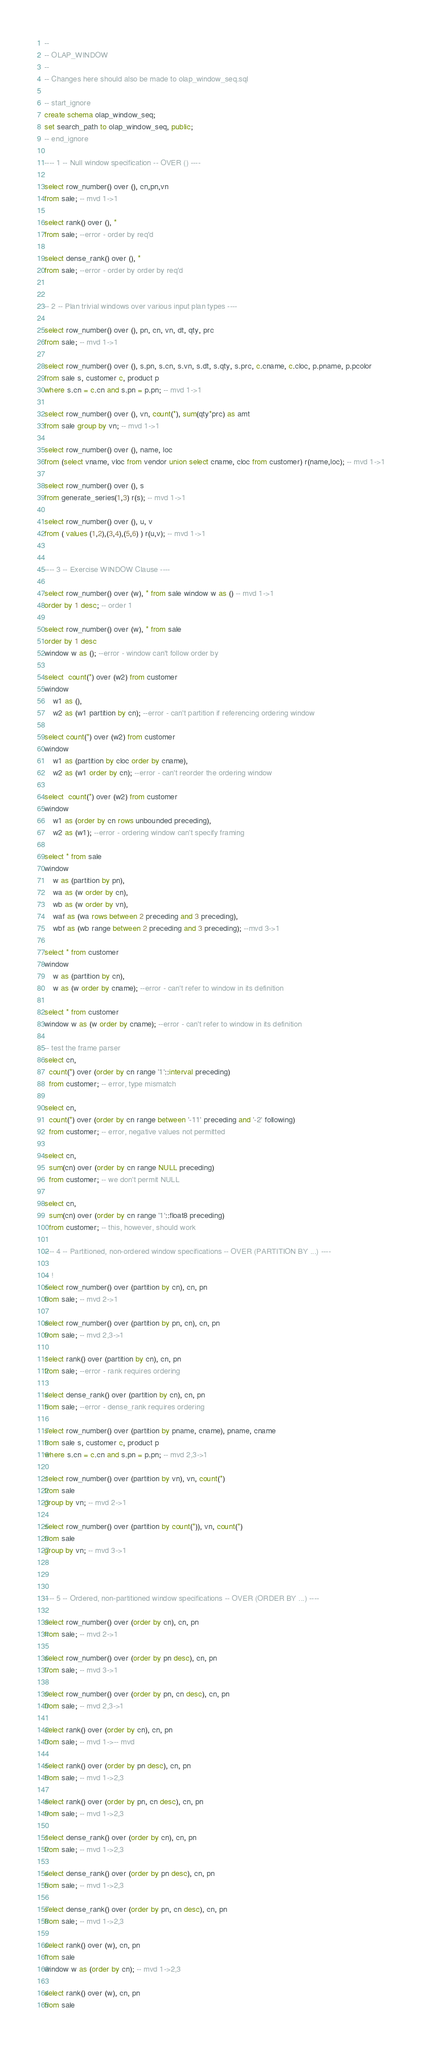Convert code to text. <code><loc_0><loc_0><loc_500><loc_500><_SQL_>--
-- OLAP_WINDOW 
--
-- Changes here should also be made to olap_window_seq.sql

-- start_ignore
create schema olap_window_seq;
set search_path to olap_window_seq, public;
-- end_ignore

---- 1 -- Null window specification -- OVER () ----

select row_number() over (), cn,pn,vn 
from sale; -- mvd 1->1

select rank() over (), * 
from sale; --error - order by req'd

select dense_rank() over (), * 
from sale; --error - order by order by req'd


-- 2 -- Plan trivial windows over various input plan types ----

select row_number() over (), pn, cn, vn, dt, qty, prc
from sale; -- mvd 1->1

select row_number() over (), s.pn, s.cn, s.vn, s.dt, s.qty, s.prc, c.cname, c.cloc, p.pname, p.pcolor
from sale s, customer c, product p 
where s.cn = c.cn and s.pn = p.pn; -- mvd 1->1

select row_number() over (), vn, count(*), sum(qty*prc) as amt
from sale group by vn; -- mvd 1->1

select row_number() over (), name, loc
from (select vname, vloc from vendor union select cname, cloc from customer) r(name,loc); -- mvd 1->1

select row_number() over (), s 
from generate_series(1,3) r(s); -- mvd 1->1

select row_number() over (), u, v
from ( values (1,2),(3,4),(5,6) ) r(u,v); -- mvd 1->1


---- 3 -- Exercise WINDOW Clause ----

select row_number() over (w), * from sale window w as () -- mvd 1->1
order by 1 desc; -- order 1

select row_number() over (w), * from sale
order by 1 desc
window w as (); --error - window can't follow order by

select  count(*) over (w2) from customer
window
    w1 as (),
    w2 as (w1 partition by cn); --error - can't partition if referencing ordering window

select count(*) over (w2) from customer
window
    w1 as (partition by cloc order by cname),
    w2 as (w1 order by cn); --error - can't reorder the ordering window

select  count(*) over (w2) from customer
window 
    w1 as (order by cn rows unbounded preceding),
    w2 as (w1); --error - ordering window can't specify framing

select * from sale
window 
    w as (partition by pn),
    wa as (w order by cn),
    wb as (w order by vn),
    waf as (wa rows between 2 preceding and 3 preceding),
    wbf as (wb range between 2 preceding and 3 preceding); --mvd 3->1
    
select * from customer
window 
    w as (partition by cn), 
    w as (w order by cname); --error - can't refer to window in its definition

select * from customer
window w as (w order by cname); --error - can't refer to window in its definition

-- test the frame parser
select cn, 
  count(*) over (order by cn range '1'::interval preceding) 
  from customer; -- error, type mismatch

select cn,
  count(*) over (order by cn range between '-11' preceding and '-2' following)
  from customer; -- error, negative values not permitted

select cn,
  sum(cn) over (order by cn range NULL preceding)
  from customer; -- we don't permit NULL

select cn,
  sum(cn) over (order by cn range '1'::float8 preceding)
  from customer; -- this, however, should work

---- 4 -- Partitioned, non-ordered window specifications -- OVER (PARTITION BY ...) ----

-- !
select row_number() over (partition by cn), cn, pn 
from sale; -- mvd 2->1

select row_number() over (partition by pn, cn), cn, pn 
from sale; -- mvd 2,3->1

select rank() over (partition by cn), cn, pn 
from sale; --error - rank requires ordering

select dense_rank() over (partition by cn), cn, pn 
from sale; --error - dense_rank requires ordering

select row_number() over (partition by pname, cname), pname, cname
from sale s, customer c, product p 
where s.cn = c.cn and s.pn = p.pn; -- mvd 2,3->1

select row_number() over (partition by vn), vn, count(*)
from sale 
group by vn; -- mvd 2->1

select row_number() over (partition by count(*)), vn, count(*)
from sale 
group by vn; -- mvd 3->1



---- 5 -- Ordered, non-partitioned window specifications -- OVER (ORDER BY ...) ----

select row_number() over (order by cn), cn, pn 
from sale; -- mvd 2->1

select row_number() over (order by pn desc), cn, pn 
from sale; -- mvd 3->1

select row_number() over (order by pn, cn desc), cn, pn 
from sale; -- mvd 2,3->1

select rank() over (order by cn), cn, pn 
from sale; -- mvd 1->-- mvd

select rank() over (order by pn desc), cn, pn 
from sale; -- mvd 1->2,3

select rank() over (order by pn, cn desc), cn, pn 
from sale; -- mvd 1->2,3

select dense_rank() over (order by cn), cn, pn 
from sale; -- mvd 1->2,3

select dense_rank() over (order by pn desc), cn, pn 
from sale; -- mvd 1->2,3

select dense_rank() over (order by pn, cn desc), cn, pn 
from sale; -- mvd 1->2,3

select rank() over (w), cn, pn 
from sale 
window w as (order by cn); -- mvd 1->2,3

select rank() over (w), cn, pn 
from sale </code> 